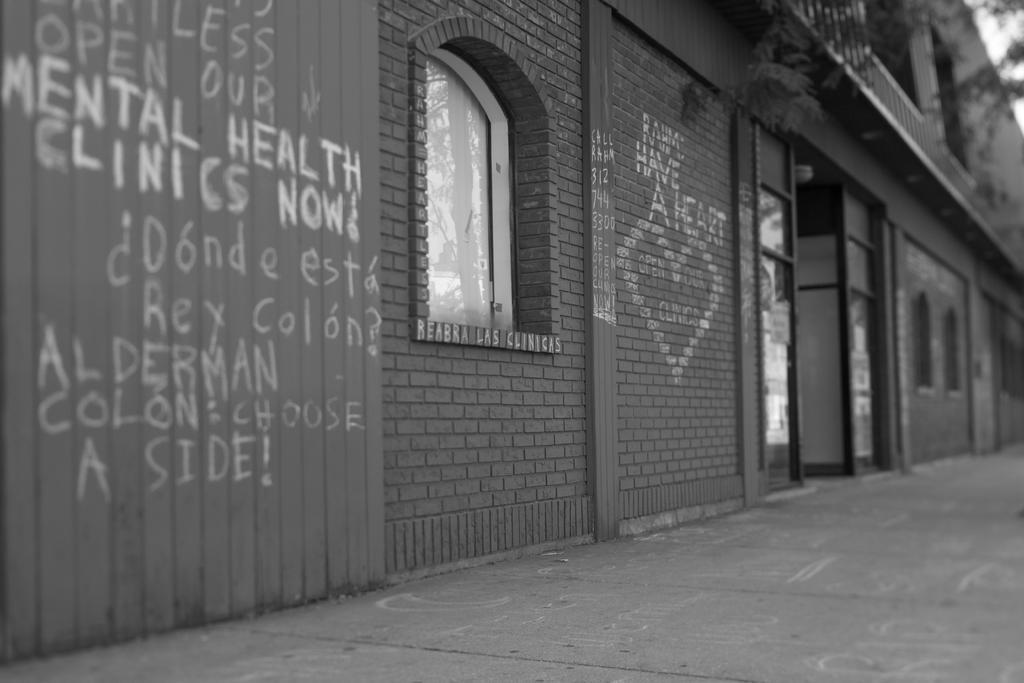Describe this image in one or two sentences. This picture is taken from outside of the building. In this image, on the left side, we can see a wall with some text written on it. On the right side, we can see some trees. In the background, we can see a building, window and a brick wall with some text written on it. At the top, we can see a sky, at the bottom, we can see a road. 